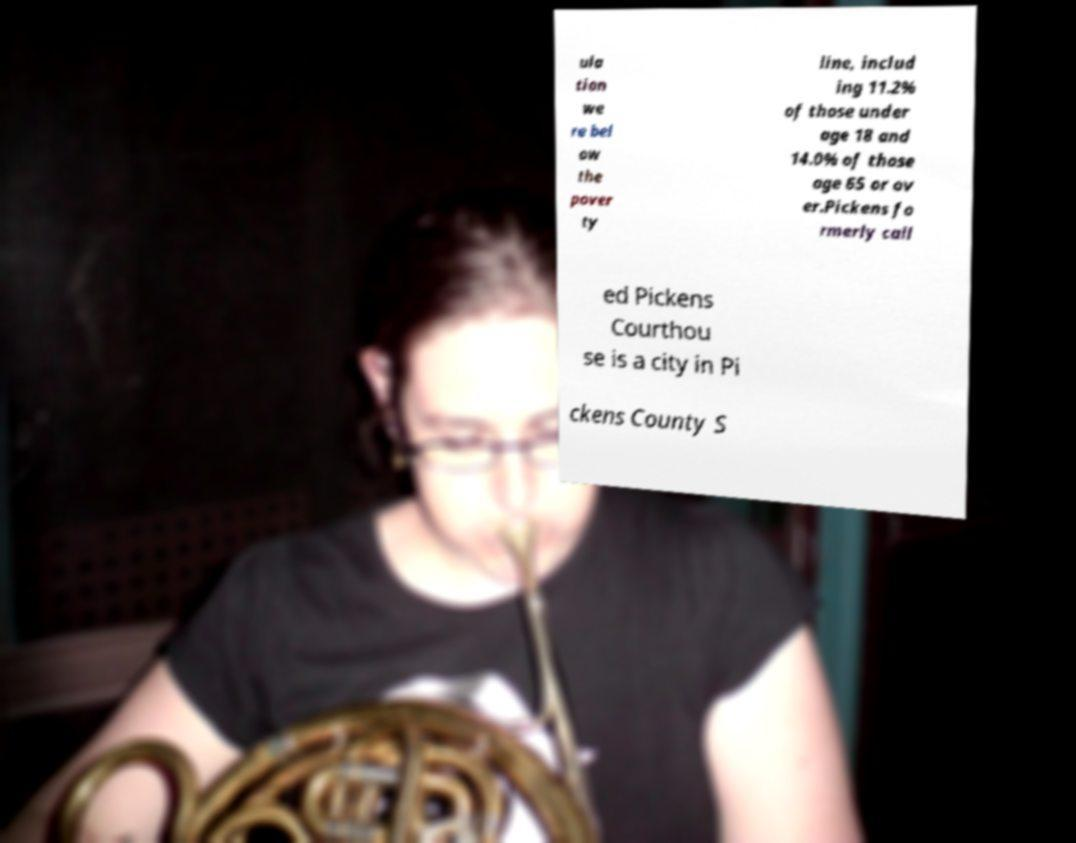Could you extract and type out the text from this image? ula tion we re bel ow the pover ty line, includ ing 11.2% of those under age 18 and 14.0% of those age 65 or ov er.Pickens fo rmerly call ed Pickens Courthou se is a city in Pi ckens County S 